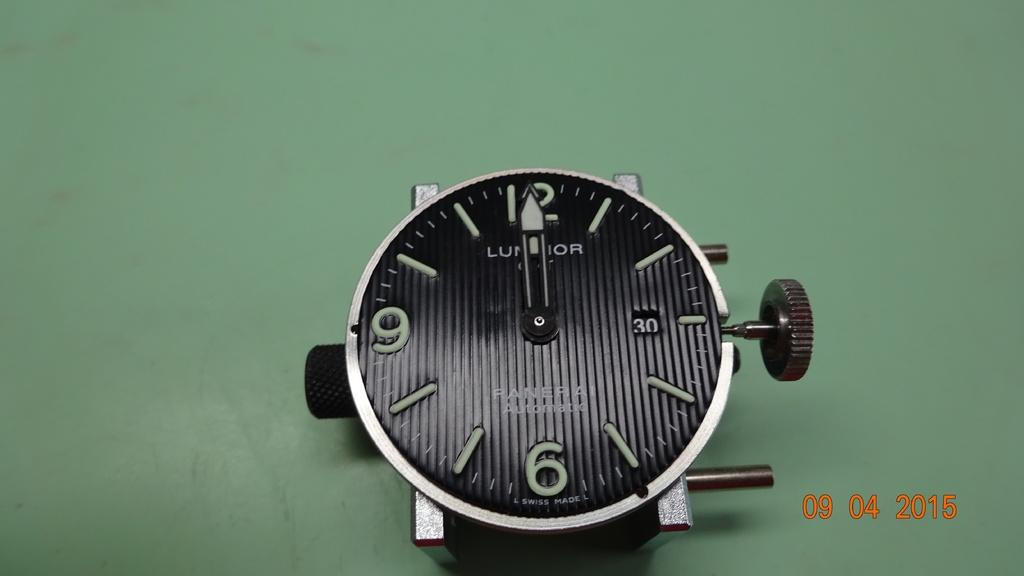<image>
Create a compact narrative representing the image presented. A black watch face is shown with the hands pointing to twelve o' clock and a 2015 time stamp in the corner. 